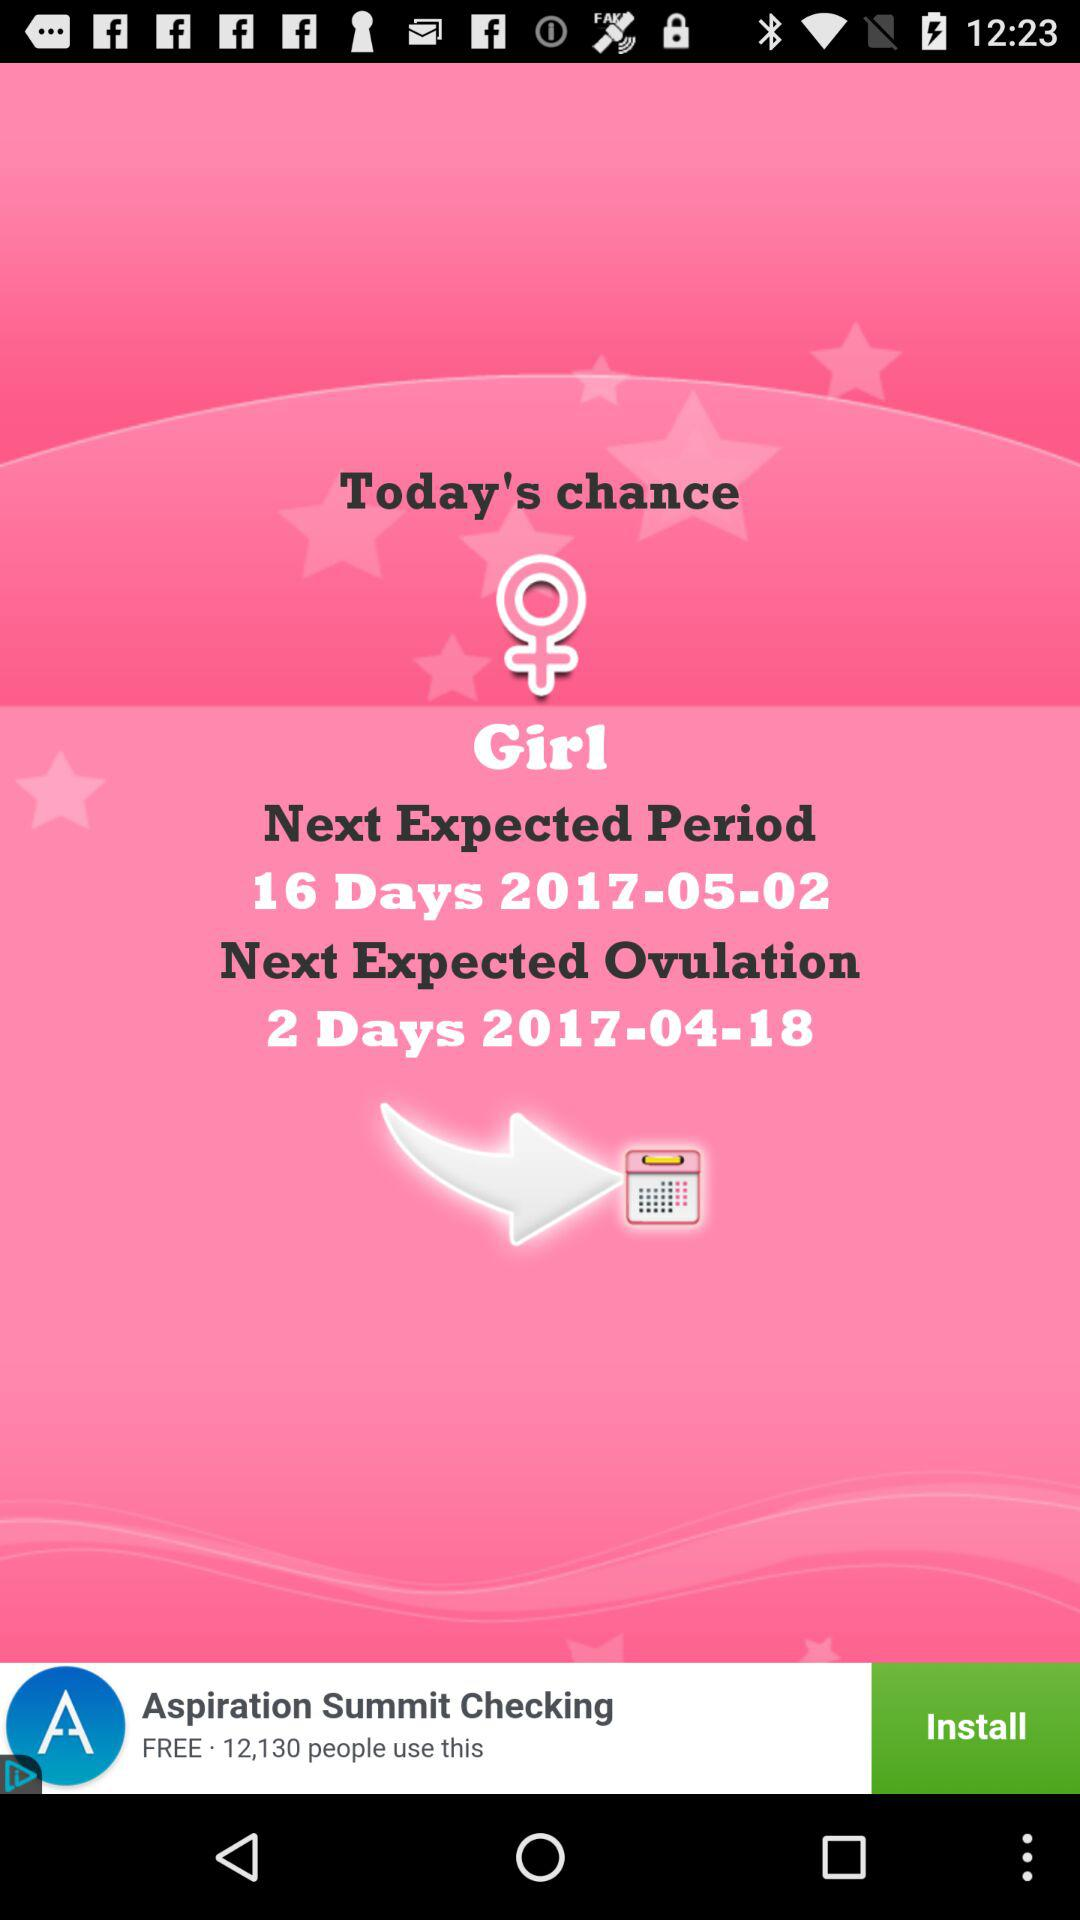What is the expected ovulation date? The expected ovulation date is April 18, 2017. 